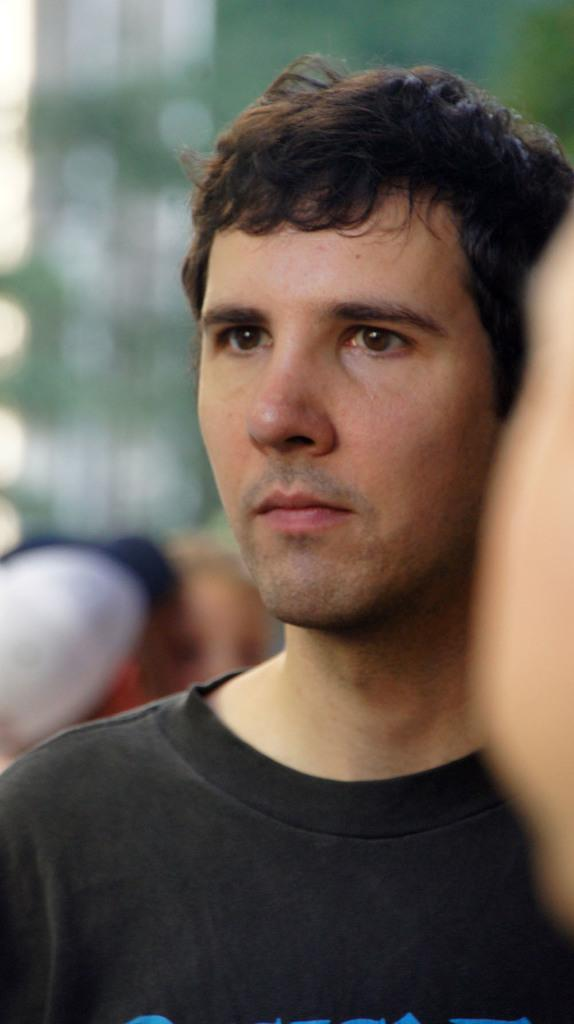Who is the main subject in the image? There is a man in the image. What is the man wearing? The man is wearing a black t-shirt. Can you describe the background of the image? The background of the image is blurred. What type of drink does the man's grandfather have in the image? There is no mention of a grandfather or a drink in the image. The image only features a man wearing a black t-shirt with a blurred background. 